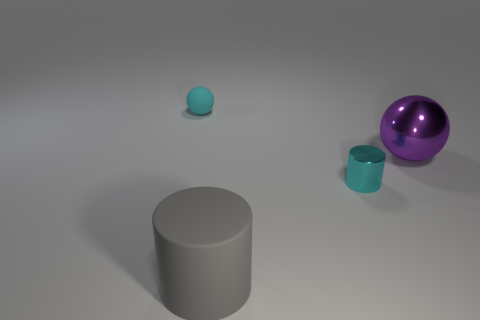Does the large gray rubber object have the same shape as the tiny cyan matte thing? No, the large gray object is cylindrical in shape, while the tiny cyan item has a spherical form, differing significantly in both shape and size. 